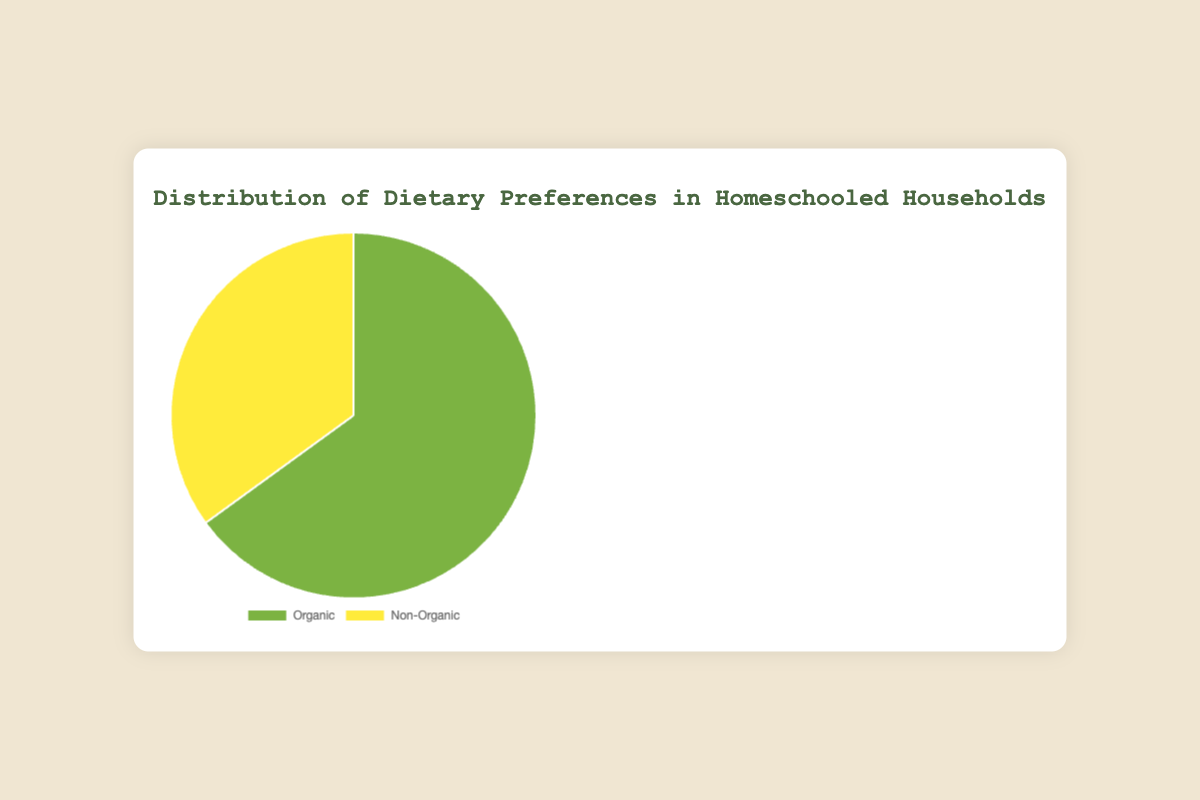What are the two dietary preferences shown in the chart? The chart displays "Organic" and "Non-Organic" as the two dietary preferences.
Answer: Organic and Non-Organic Which dietary preference has a higher percentage in homeschooled households? By looking at the chart, the "Organic" category has a higher percentage compared to "Non-Organic".
Answer: Organic What percentage of homeschooled households prefer organic diets? The chart shows that the "Organic" category represents 65% of the total dietary preferences.
Answer: 65% How much greater is the percentage of households that prefer organic diets compared to non-organic diets? The "Organic" category is 65% and the "Non-Organic" category is 35%. The difference is 65% - 35% = 30%.
Answer: 30% What is the combined percentage of households that prefer either organic or non-organic diets? Adding the percentage of "Organic" (65%) and "Non-Organic" (35%) gives 65% + 35% = 100%.
Answer: 100% Which color represents the organic dietary preference? The segment representing "Organic" is colored green in the pie chart.
Answer: Green What is the ratio of organic to non-organic dietary preferences among homeschooled households? The percentage for "Organic" is 65%, and for "Non-Organic," it is 35%. The ratio is 65:35, which simplifies to 13:7.
Answer: 13:7 If there are 400 homeschooled households, how many prefer non-organic diets? 35% of 400 is found by calculating 0.35 * 400 = 140. Thus, 140 households prefer non-organic diets.
Answer: 140 What would be the percentage of organic dietary preference if 10% more households switched to organic? Currently, 65% prefer organic. If an additional 10% switch, it would be 65% + 10% = 75%.
Answer: 75% Comparing visual attributes, which segment of the pie chart is larger? The "Organic" segment is visually larger than the "Non-Organic" segment.
Answer: Organic 